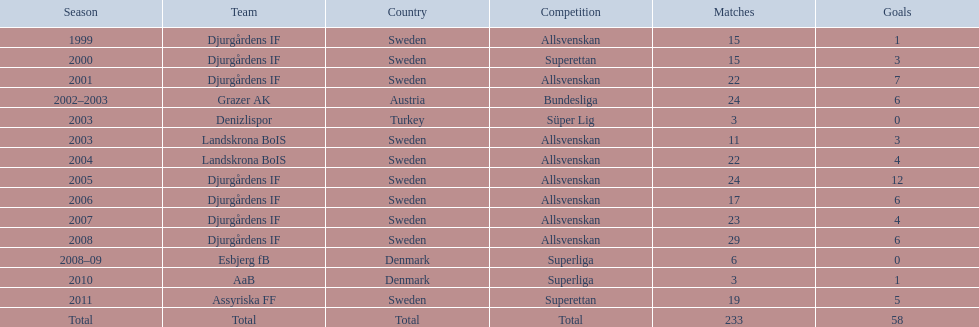What was the quantity of goals he scored in 2005? 12. 